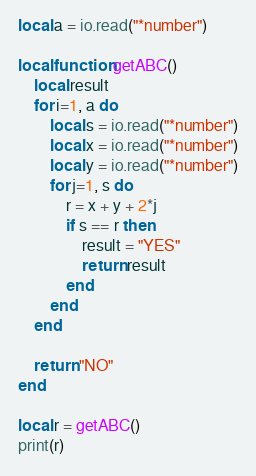Convert code to text. <code><loc_0><loc_0><loc_500><loc_500><_Lua_>local a = io.read("*number")

local function getABC()
	local result
	for i=1, a do
		local s = io.read("*number")
		local x = io.read("*number")
		local y = io.read("*number")
		for j=1, s do
			r = x + y + 2*j
			if s == r then
				result = "YES"
				return result
			end
		end
	end

	return "NO"
end

local r = getABC()
print(r)
</code> 